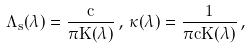<formula> <loc_0><loc_0><loc_500><loc_500>\Lambda _ { s } ( \lambda ) = \frac { c } { \pi K ( \lambda ) } \, , \, \kappa ( \lambda ) = \frac { 1 } { \pi c K ( \lambda ) } \, ,</formula> 